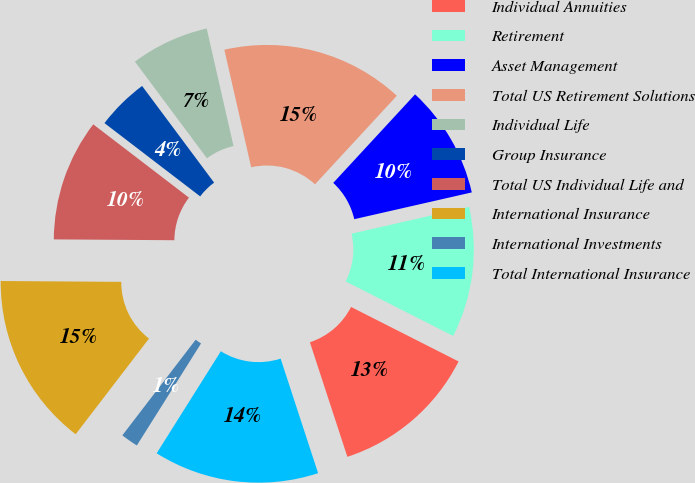Convert chart. <chart><loc_0><loc_0><loc_500><loc_500><pie_chart><fcel>Individual Annuities<fcel>Retirement<fcel>Asset Management<fcel>Total US Retirement Solutions<fcel>Individual Life<fcel>Group Insurance<fcel>Total US Individual Life and<fcel>International Insurance<fcel>International Investments<fcel>Total International Insurance<nl><fcel>12.5%<fcel>11.03%<fcel>9.56%<fcel>15.44%<fcel>6.62%<fcel>4.41%<fcel>10.29%<fcel>14.7%<fcel>1.47%<fcel>13.97%<nl></chart> 